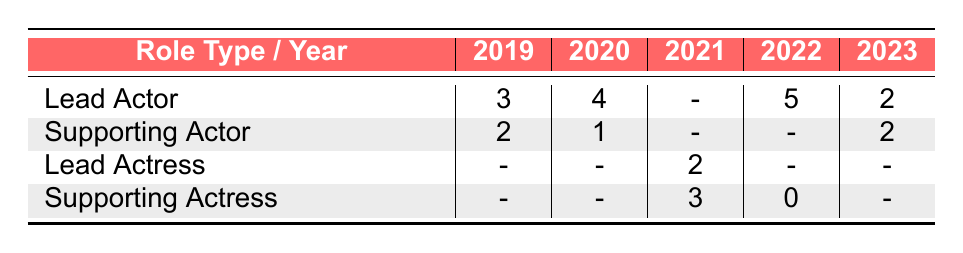What is the total number of Lead Actor nominations from 2019 to 2023? The Lead Actor nominations for the years are 3 (2019), 4 (2020), 5 (2022), and 2 (2023). We don't have data for 2021. Summing these values gives 3 + 4 + 5 + 2 = 14.
Answer: 14 How many nominations did Supporting Actress receive in 2022? The table shows that Supporting Actress received 0 nominations in 2022 directly.
Answer: 0 Did the number of Lead Actor nominations increase from 2019 to 2020? In 2019, there were 3 nominations, and in 2020, there were 4 nominations. Since 4 is greater than 3, we conclude that there was an increase.
Answer: Yes What is the average number of Supporting Actor nominations across all years shown? The Supporting Actor nominations were 2 (2019), 1 (2020), and 2 (2023). We don't have data for 2021 and 2022, so we have 3 data points: 2 + 1 + 2 = 5. The average is 5 / 3 = 1.67.
Answer: 1.67 In which year did Lead Actress receive the most nominations? The table shows that Lead Actress received nominations in one year only, which is 2021 with 2 nominations. Since there are no nominations in other years, 2021 is the only year.
Answer: 2021 How many total nominations were there for Supporting Actress across all years? The nominations for Supporting Actress were 3 (2021) and 0 (2022). There is no data for 2019, 2020, and 2023. Hence, the total nominations are 3 + 0 = 3.
Answer: 3 Which role type had the highest number of nominations in 2022? In 2022, Lead Actor had 5 nominations, while Supporting Actress had 0. Hence, Lead Actor had the highest nominations that year.
Answer: Lead Actor Is it true that there were no nominations for Supporting Actress in 2023? The table does not show any nominations for Supporting Actress in 2023, confirming the statement is true.
Answer: Yes What was the change in Supporting Actor nominations from 2019 to 2020? In 2019, Supporting Actor received 2 nominations, and in 2020, it received 1 nomination. This is a decrease of 1 nomination (2 - 1 = 1).
Answer: 1 decrease 